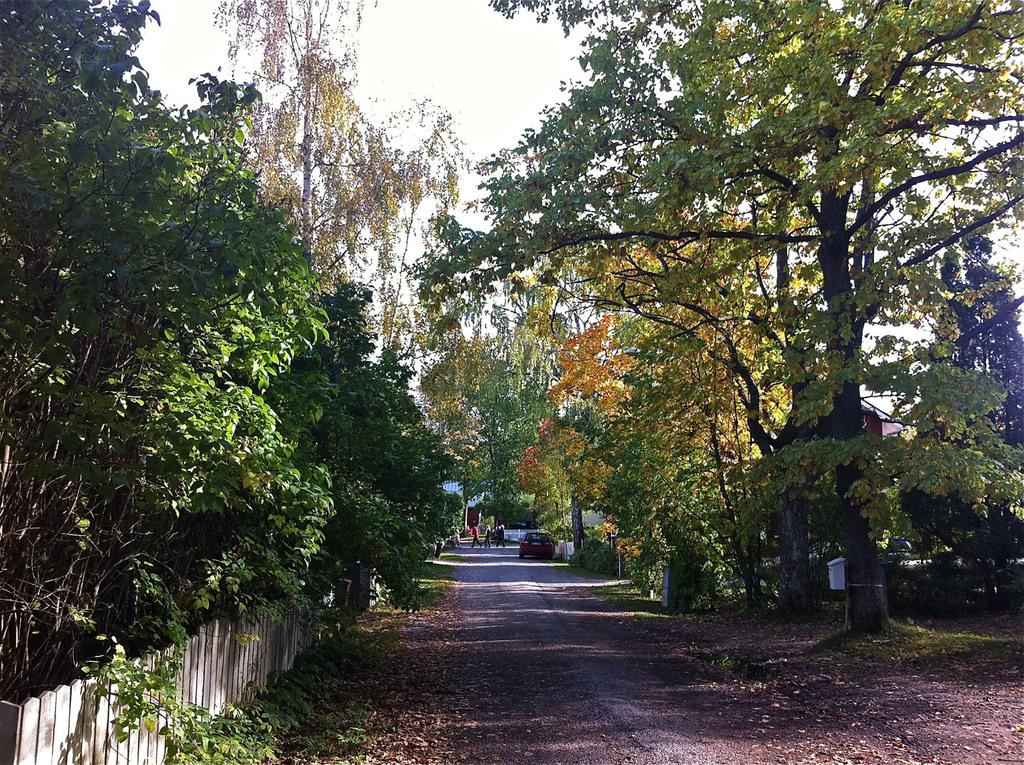What type of vegetation can be seen in the image? There are trees and plants in the image. What type of structure is visible in the image? There is a wooden wall in the image. What type of vehicle is present in the image? There is a car in the image. How many people are in the image? There is a group of people in the image. What is visible at the top of the image? The sky is visible at the top of the image. Can you tell me where the vein is located in the image? There is no vein present in the image. What type of shop can be seen in the image? There is no shop present in the image. 